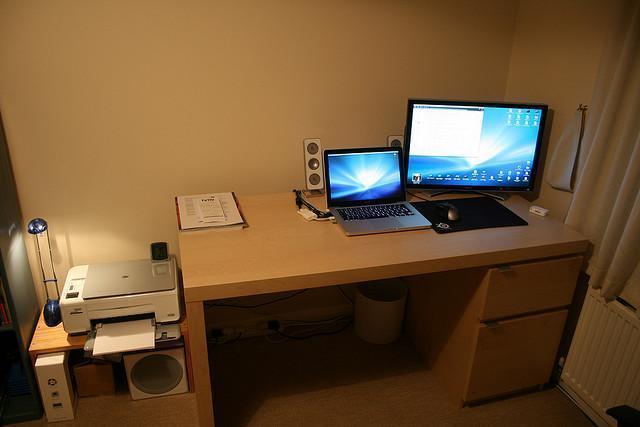What is this desk made of?
Indicate the correct response and explain using: 'Answer: answer
Rationale: rationale.'
Options: Laminated wood, oak, pine, plywood. Answer: laminated wood.
Rationale: The desk is wooden. 